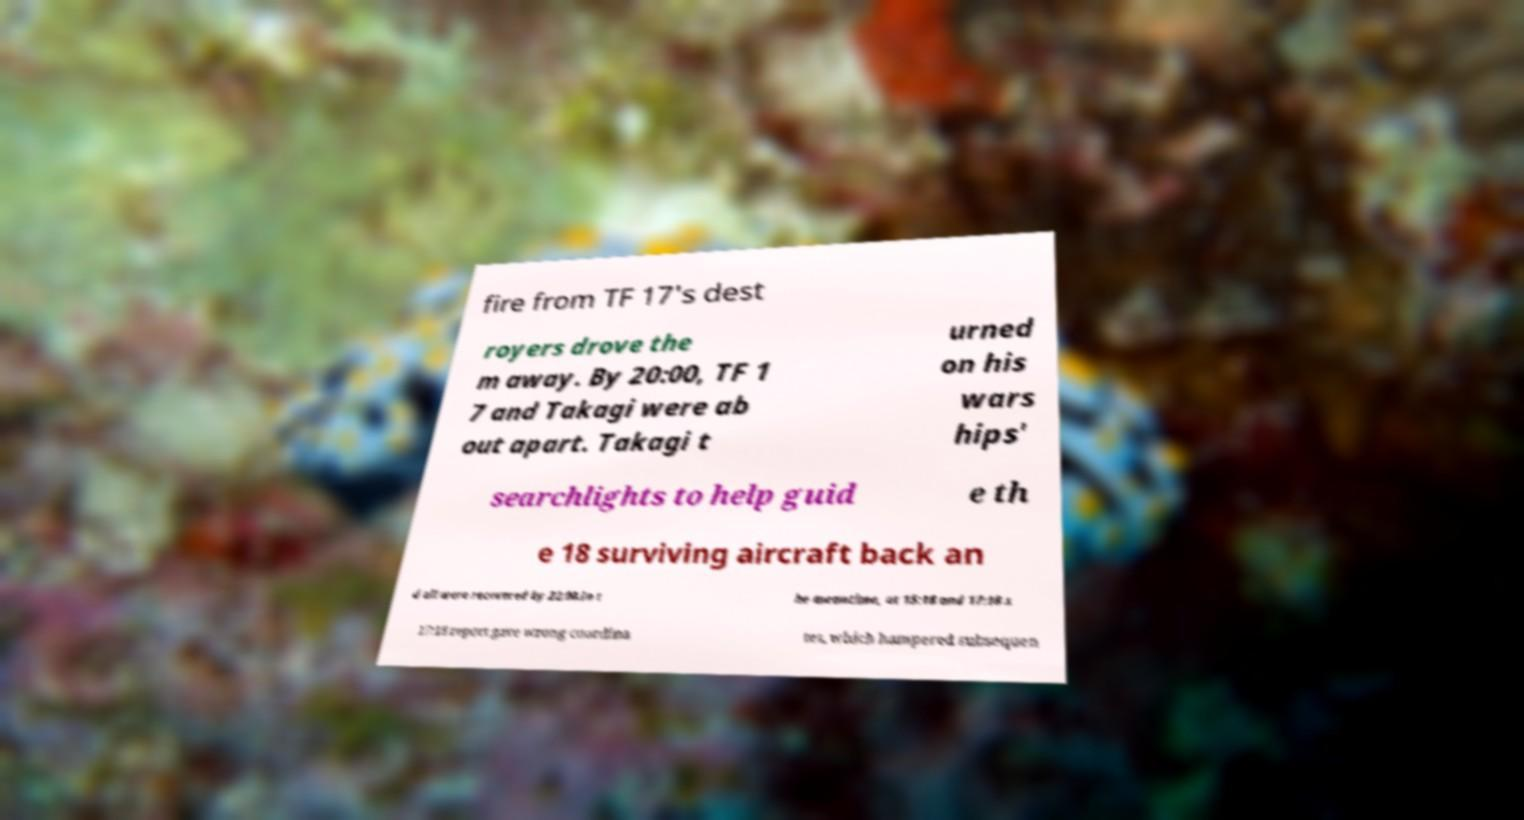There's text embedded in this image that I need extracted. Can you transcribe it verbatim? fire from TF 17's dest royers drove the m away. By 20:00, TF 1 7 and Takagi were ab out apart. Takagi t urned on his wars hips' searchlights to help guid e th e 18 surviving aircraft back an d all were recovered by 22:00.In t he meantime, at 15:18 and 17:18 s 17:18 report gave wrong coordina tes, which hampered subsequen 